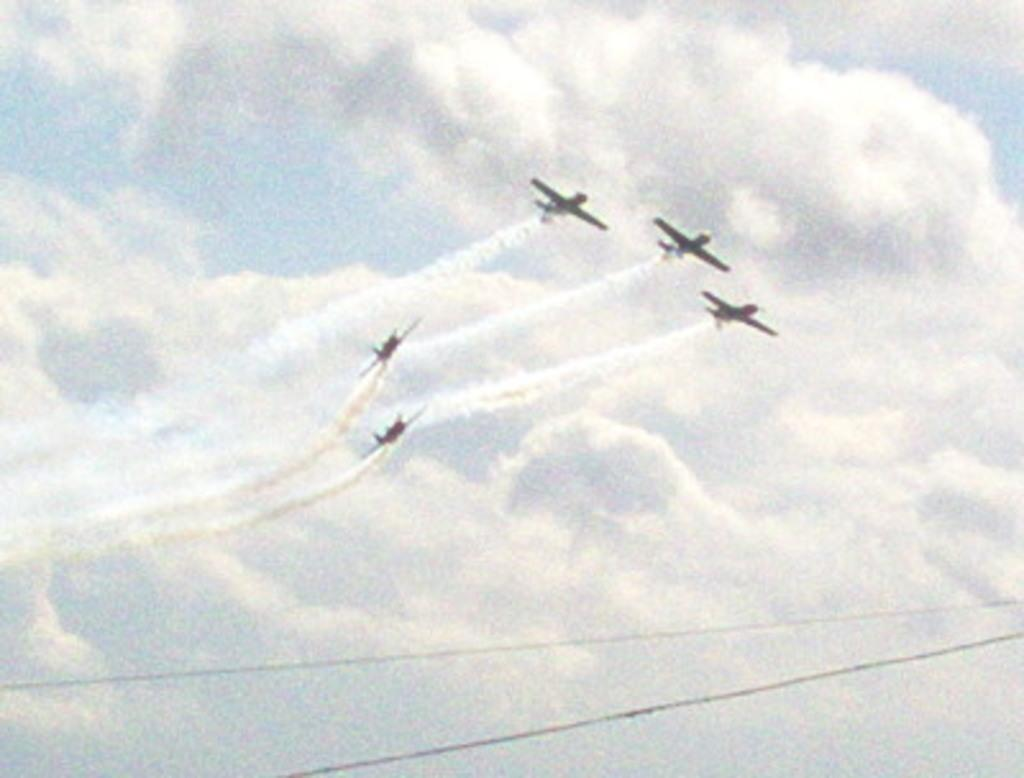How many jet aircrafts are visible in the image? There are five jet aircrafts in the image. What are the jet aircrafts doing in the image? The jet aircrafts are flying in the sky. What can be seen at the bottom of the image? There appear to be wires at the bottom of the image. What type of cough medicine is being advertised on the jet aircrafts in the image? There is no cough medicine or advertisement present on the jet aircrafts in the image; they are simply flying in the sky. 